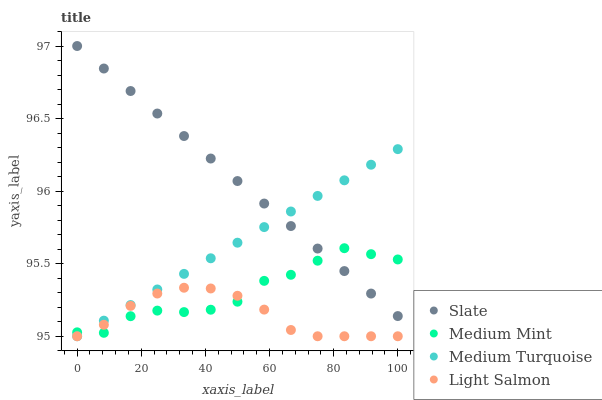Does Light Salmon have the minimum area under the curve?
Answer yes or no. Yes. Does Slate have the maximum area under the curve?
Answer yes or no. Yes. Does Slate have the minimum area under the curve?
Answer yes or no. No. Does Light Salmon have the maximum area under the curve?
Answer yes or no. No. Is Slate the smoothest?
Answer yes or no. Yes. Is Medium Mint the roughest?
Answer yes or no. Yes. Is Light Salmon the smoothest?
Answer yes or no. No. Is Light Salmon the roughest?
Answer yes or no. No. Does Light Salmon have the lowest value?
Answer yes or no. Yes. Does Slate have the lowest value?
Answer yes or no. No. Does Slate have the highest value?
Answer yes or no. Yes. Does Light Salmon have the highest value?
Answer yes or no. No. Is Light Salmon less than Slate?
Answer yes or no. Yes. Is Slate greater than Light Salmon?
Answer yes or no. Yes. Does Light Salmon intersect Medium Turquoise?
Answer yes or no. Yes. Is Light Salmon less than Medium Turquoise?
Answer yes or no. No. Is Light Salmon greater than Medium Turquoise?
Answer yes or no. No. Does Light Salmon intersect Slate?
Answer yes or no. No. 